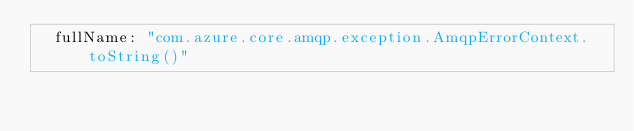Convert code to text. <code><loc_0><loc_0><loc_500><loc_500><_YAML_>  fullName: "com.azure.core.amqp.exception.AmqpErrorContext.toString()"</code> 